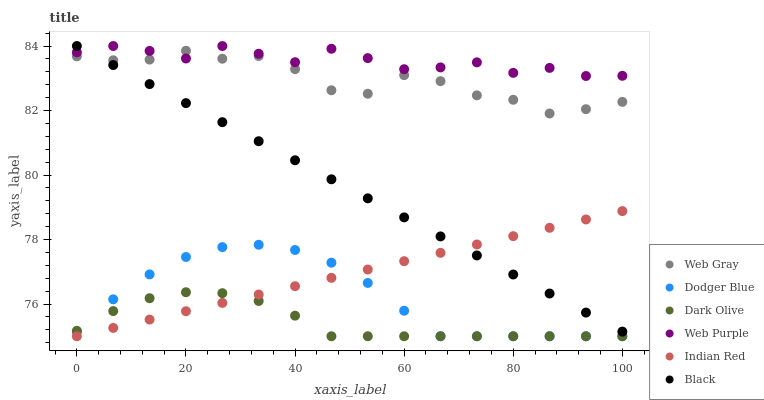Does Dark Olive have the minimum area under the curve?
Answer yes or no. Yes. Does Web Purple have the maximum area under the curve?
Answer yes or no. Yes. Does Web Purple have the minimum area under the curve?
Answer yes or no. No. Does Dark Olive have the maximum area under the curve?
Answer yes or no. No. Is Black the smoothest?
Answer yes or no. Yes. Is Web Gray the roughest?
Answer yes or no. Yes. Is Dark Olive the smoothest?
Answer yes or no. No. Is Dark Olive the roughest?
Answer yes or no. No. Does Dark Olive have the lowest value?
Answer yes or no. Yes. Does Web Purple have the lowest value?
Answer yes or no. No. Does Black have the highest value?
Answer yes or no. Yes. Does Dark Olive have the highest value?
Answer yes or no. No. Is Dark Olive less than Black?
Answer yes or no. Yes. Is Web Gray greater than Indian Red?
Answer yes or no. Yes. Does Black intersect Web Purple?
Answer yes or no. Yes. Is Black less than Web Purple?
Answer yes or no. No. Is Black greater than Web Purple?
Answer yes or no. No. Does Dark Olive intersect Black?
Answer yes or no. No. 